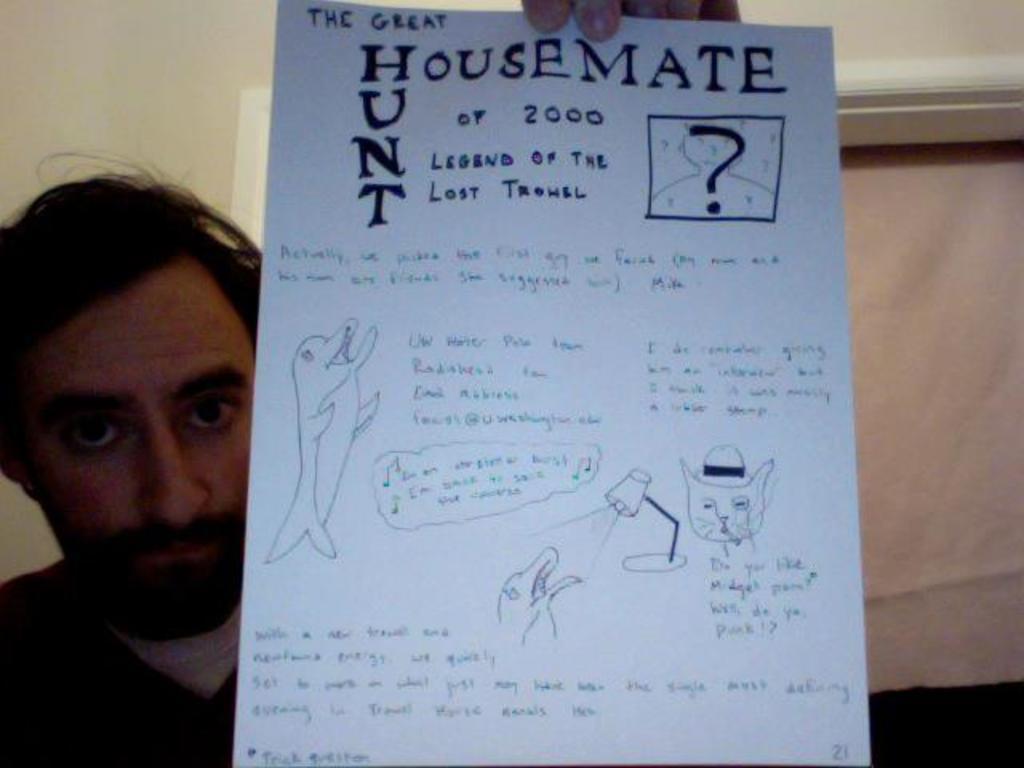Could you give a brief overview of what you see in this image? In this image I can see a person wearing white and black colored dress is holding a paper in his hand and I can see something is written on the paper with the black colored pen. In the background I can see the wall and the cream colored cloth. 